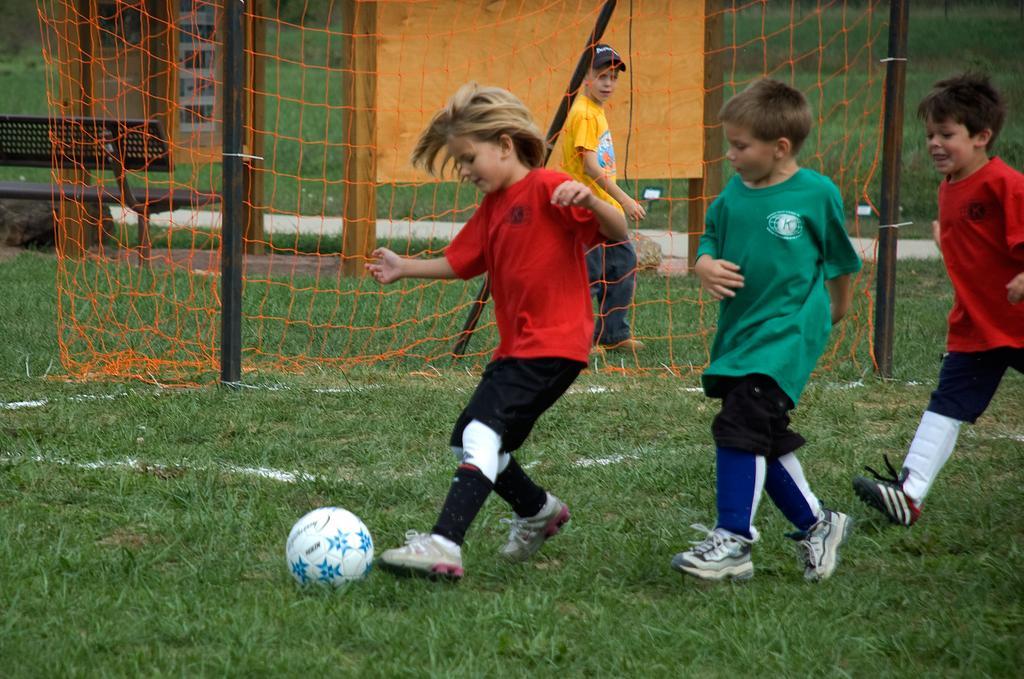Describe this image in one or two sentences. In this picture here we see 3 people who are playing foot ball and at the back of them we have net. Also at the back there is another boy who wears cap. In the foreground all the 3 boys wear shoes. 